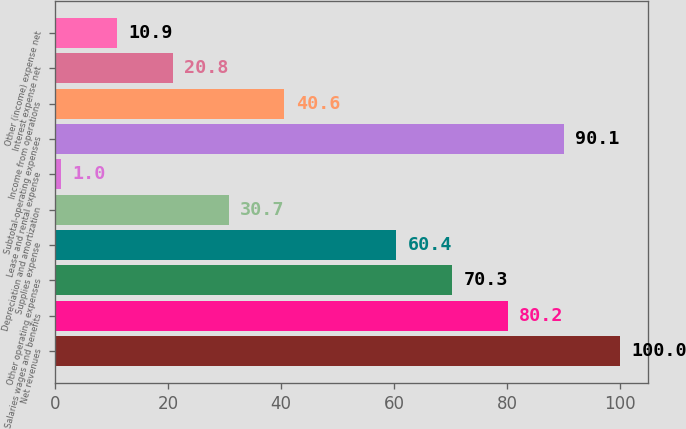Convert chart. <chart><loc_0><loc_0><loc_500><loc_500><bar_chart><fcel>Net revenues<fcel>Salaries wages and benefits<fcel>Other operating expenses<fcel>Supplies expense<fcel>Depreciation and amortization<fcel>Lease and rental expense<fcel>Subtotal-operating expenses<fcel>Income from operations<fcel>Interest expense net<fcel>Other (income) expense net<nl><fcel>100<fcel>80.2<fcel>70.3<fcel>60.4<fcel>30.7<fcel>1<fcel>90.1<fcel>40.6<fcel>20.8<fcel>10.9<nl></chart> 